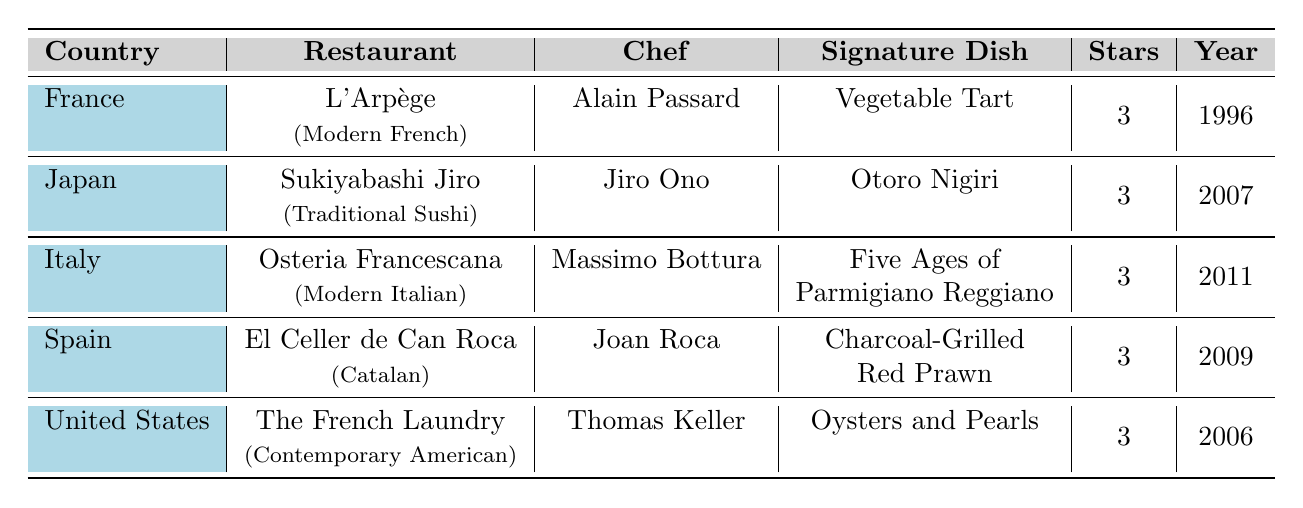What is the signature dish of L'Arpège? The table lists “L'Arpège” under the restaurant column, and the corresponding signature dish is “Vegetable Tart.”
Answer: Vegetable Tart Which country has the restaurant Sukiyabashi Jiro? By checking the country column that corresponds to the restaurant name “Sukiyabashi Jiro,” we find it listed under Japan.
Answer: Japan How many stars does Osteria Francescana have? Looking at the table, Osteria Francescana is noted to have 3 stars in the column for stars.
Answer: 3 Who is the chef of El Celler de Can Roca? The table shows that Joan Roca is listed as the chef corresponding to the restaurant name “El Celler de Can Roca.”
Answer: Joan Roca What year was The French Laundry awarded its Michelin stars? The table indicates that The French Laundry was awarded its stars in the year 2006.
Answer: 2006 Which restaurant has the signature dish called "Oysters and Pearls"? By inspecting the table, "Oysters and Pearls" is listed under the signature dish column for The French Laundry.
Answer: The French Laundry How many restaurants listed in the table are located in Italy? The table features only one restaurant listed under Italy, which is Osteria Francescana.
Answer: 1 Is the cuisine style of L'Arpège categorized as Contemporary American? Checking the cuisine style column, L'Arpège is categorized as Modern French, not Contemporary American. Therefore, this statement is false.
Answer: False Which country has the most restaurants listed in the table? The table contains one restaurant from each of the five countries, so they all have the same number.
Answer: None; all have one each List the signature dishes of the restaurants from Spain and Italy. For Spain (El Celler de Can Roca), the signature dish is “Charcoal-Grilled Red Prawn,” and for Italy (Osteria Francescana), it is “Five Ages of Parmigiano Reggiano.”
Answer: Charcoal-Grilled Red Prawn; Five Ages of Parmigiano Reggiano What is the average year awarded for the restaurants listed in the table? The years awarded are 1996, 2007, 2011, 2009, and 2006. To find the average, we sum them up (1996 + 2007 + 2011 + 2009 + 2006 = 10029), then divide by 5, giving 10029/5 = 2005.8, which rounds to 2006.
Answer: 2006 